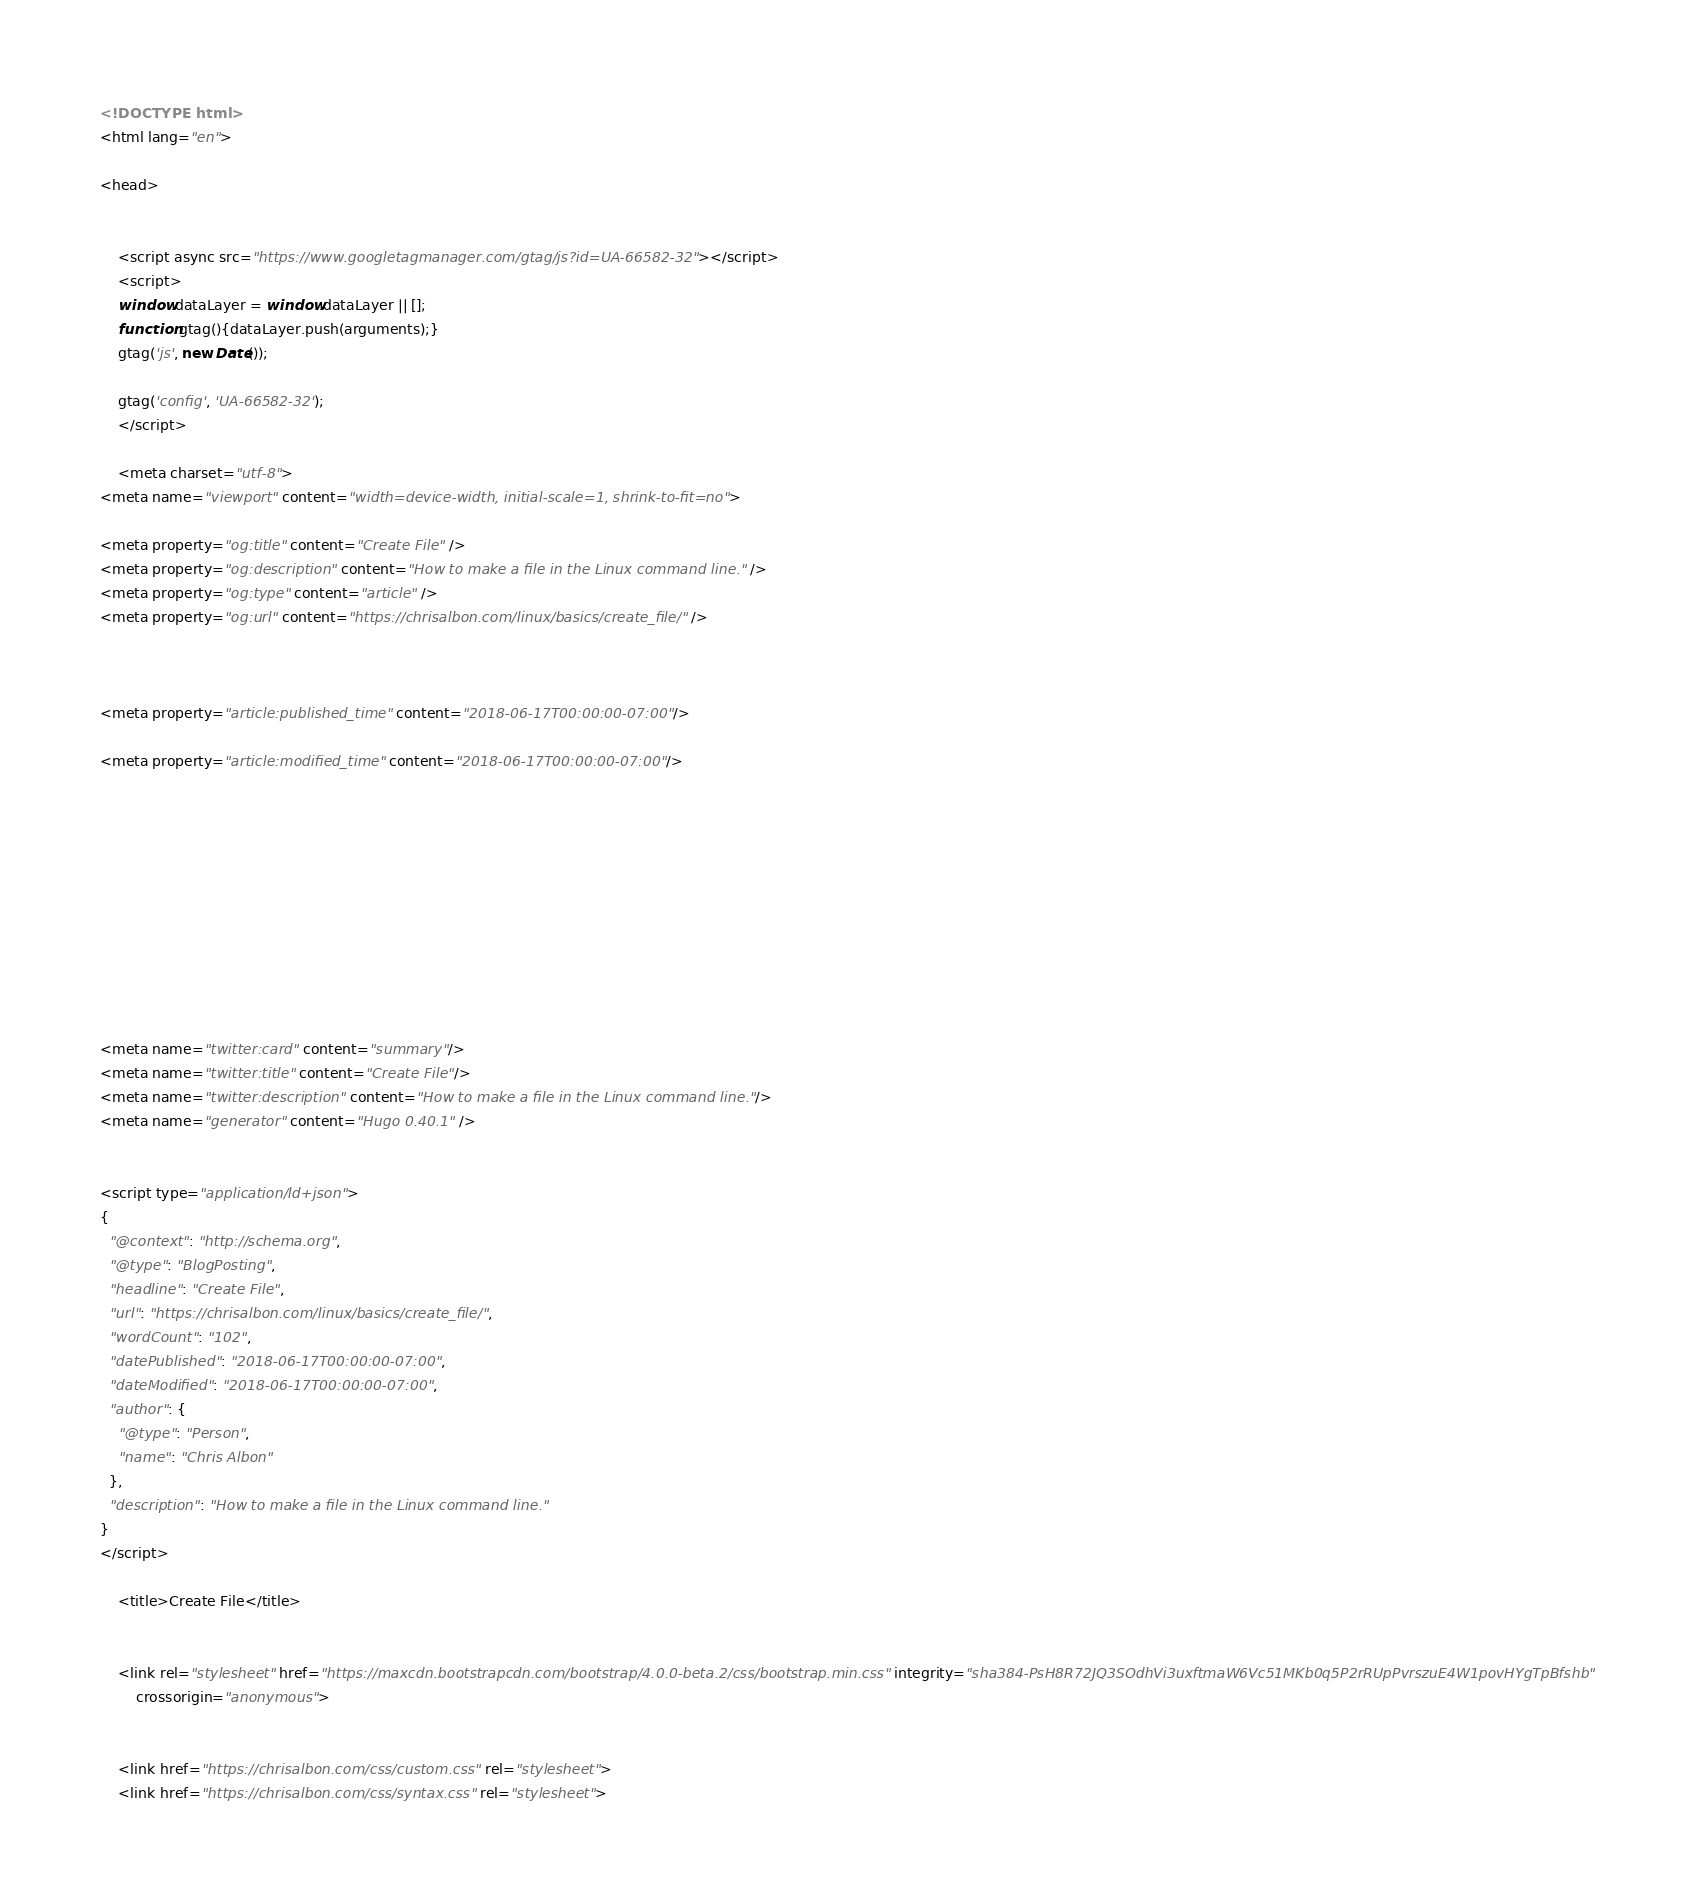Convert code to text. <code><loc_0><loc_0><loc_500><loc_500><_HTML_><!DOCTYPE html>
<html lang="en">

<head>

    
    <script async src="https://www.googletagmanager.com/gtag/js?id=UA-66582-32"></script>
    <script>
    window.dataLayer = window.dataLayer || [];
    function gtag(){dataLayer.push(arguments);}
    gtag('js', new Date());

    gtag('config', 'UA-66582-32');
    </script>

    <meta charset="utf-8">
<meta name="viewport" content="width=device-width, initial-scale=1, shrink-to-fit=no">

<meta property="og:title" content="Create File" />
<meta property="og:description" content="How to make a file in the Linux command line." />
<meta property="og:type" content="article" />
<meta property="og:url" content="https://chrisalbon.com/linux/basics/create_file/" />



<meta property="article:published_time" content="2018-06-17T00:00:00-07:00"/>

<meta property="article:modified_time" content="2018-06-17T00:00:00-07:00"/>











<meta name="twitter:card" content="summary"/>
<meta name="twitter:title" content="Create File"/>
<meta name="twitter:description" content="How to make a file in the Linux command line."/>
<meta name="generator" content="Hugo 0.40.1" />

    
<script type="application/ld+json">
{
  "@context": "http://schema.org",
  "@type": "BlogPosting",
  "headline": "Create File",
  "url": "https://chrisalbon.com/linux/basics/create_file/",
  "wordCount": "102",
  "datePublished": "2018-06-17T00:00:00-07:00",
  "dateModified": "2018-06-17T00:00:00-07:00",
  "author": {
    "@type": "Person",
    "name": "Chris Albon"
  },
  "description": "How to make a file in the Linux command line."
}
</script> 

    <title>Create File</title>

    
    <link rel="stylesheet" href="https://maxcdn.bootstrapcdn.com/bootstrap/4.0.0-beta.2/css/bootstrap.min.css" integrity="sha384-PsH8R72JQ3SOdhVi3uxftmaW6Vc51MKb0q5P2rRUpPvrszuE4W1povHYgTpBfshb"
        crossorigin="anonymous">

    
    <link href="https://chrisalbon.com/css/custom.css" rel="stylesheet"> 
    <link href="https://chrisalbon.com/css/syntax.css" rel="stylesheet"></code> 